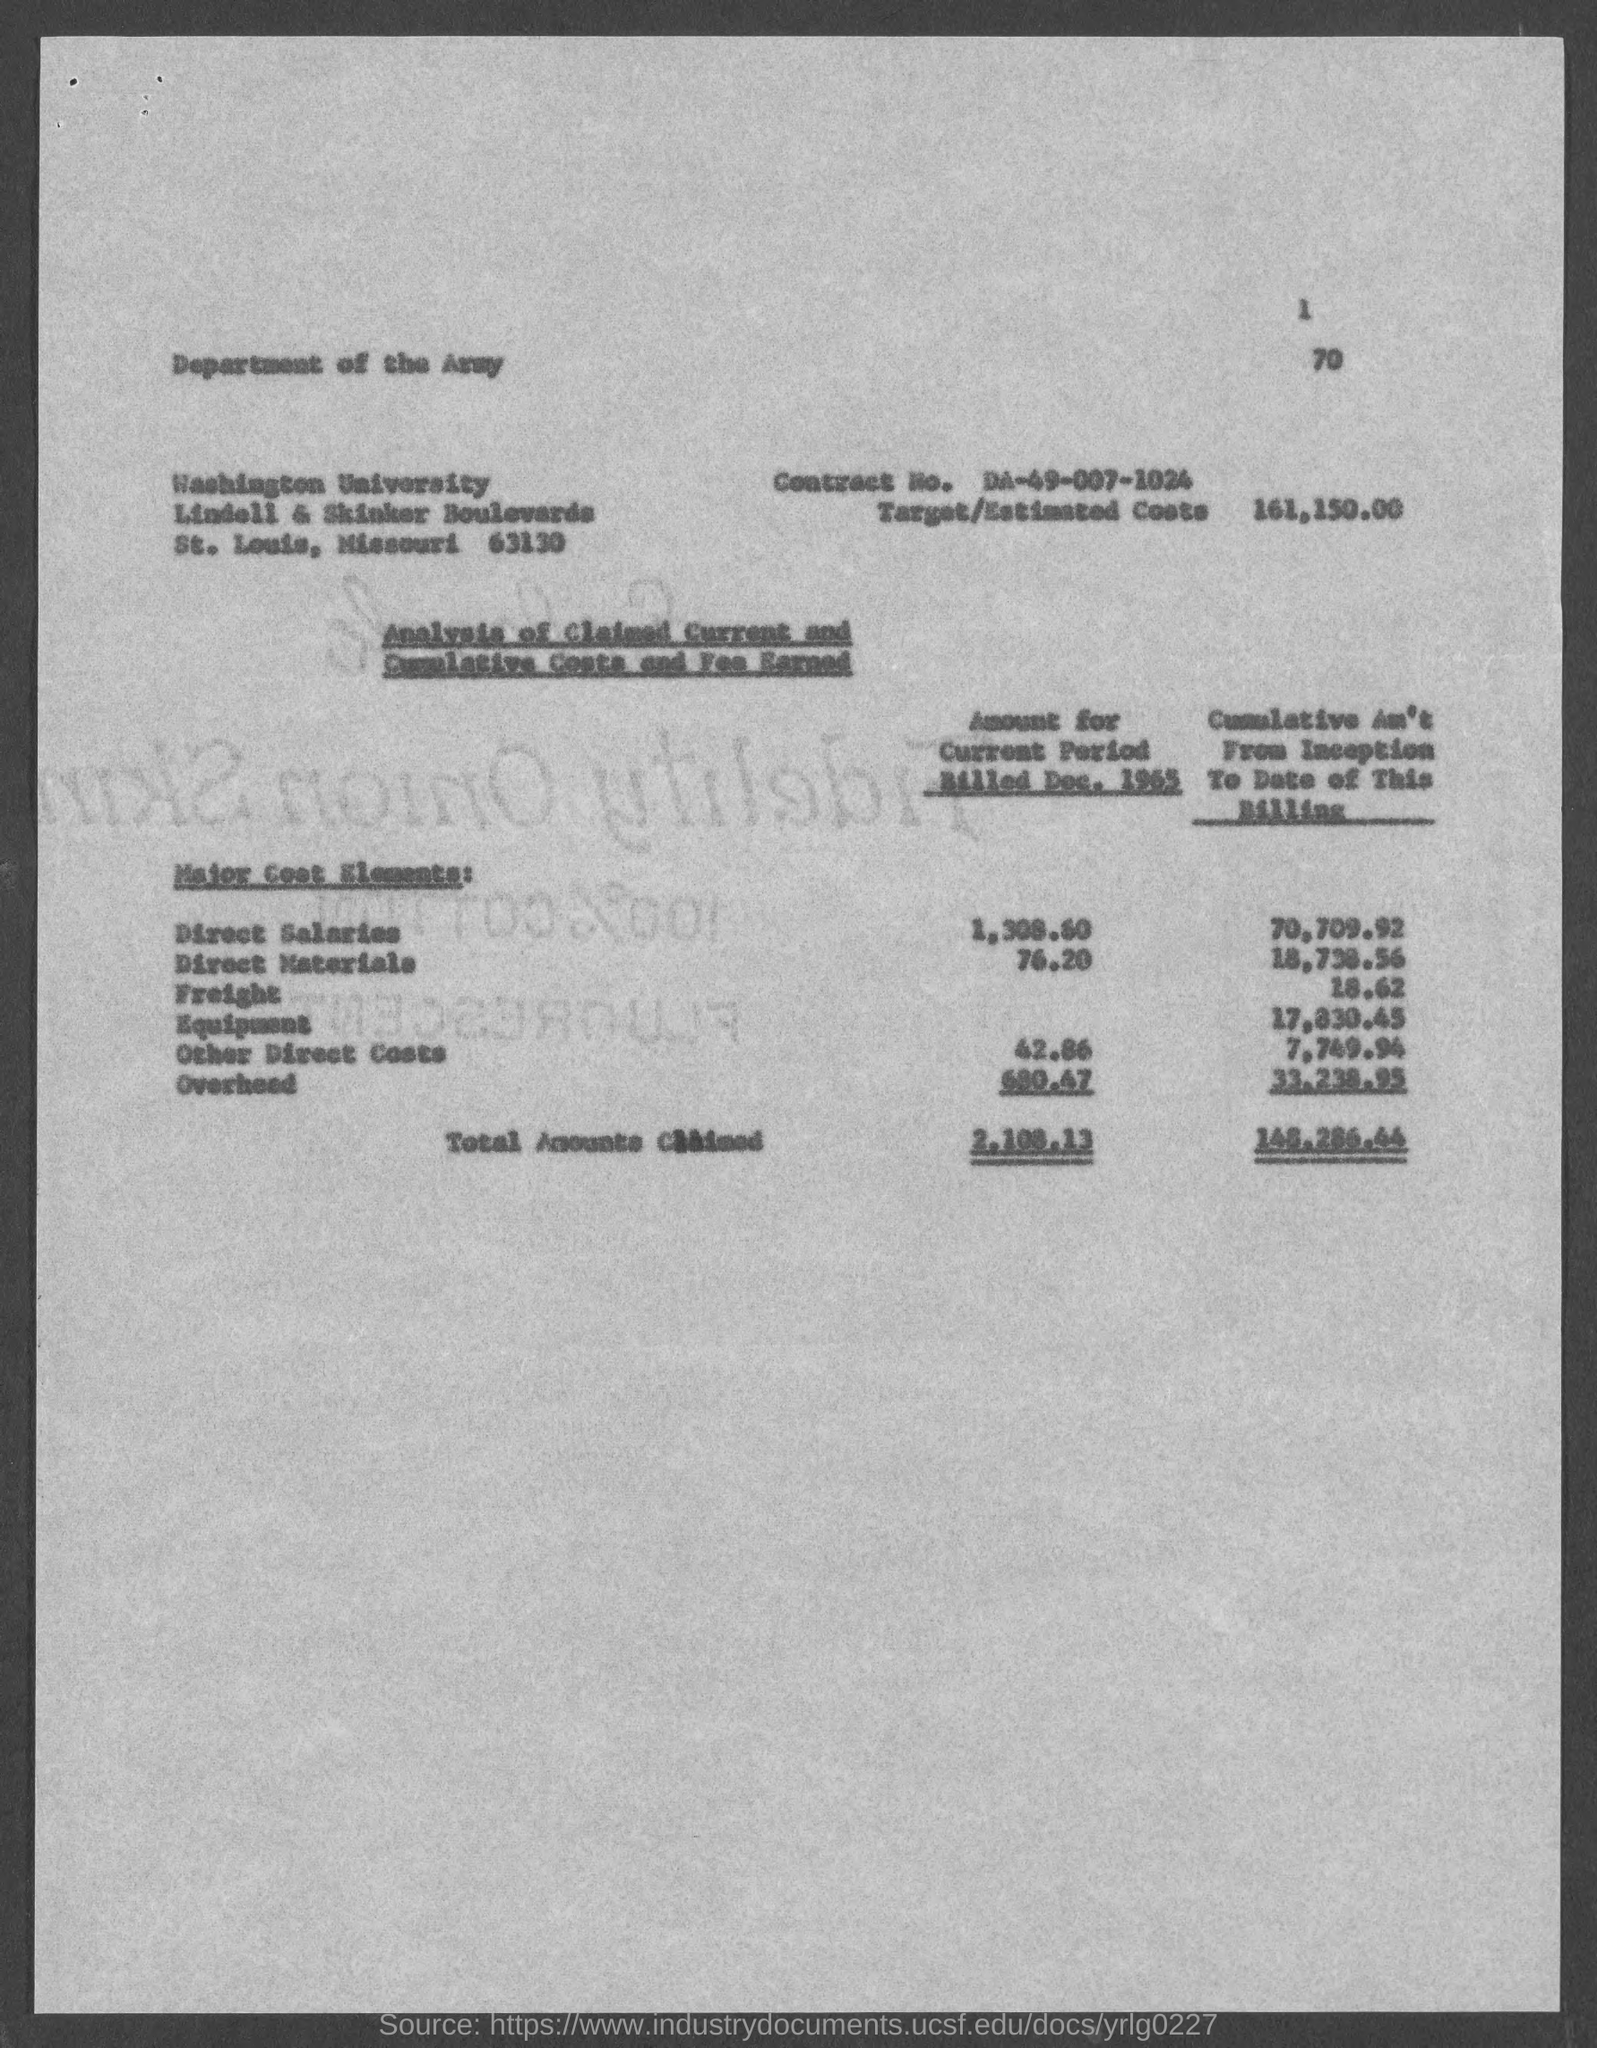What is the Target/Estimated costs given in the document?
Offer a terse response. 161,150.00. What is the direct materials amount for the current period billed in Dec. 1965?
Keep it short and to the point. 76.20. What is the cumulative amount for Freight from inception to date of this billing?
Your answer should be very brief. 18.62. What is the cumulative amount for equipment from inception to date of this billing?
Your response must be concise. 17,830.45. What is the total amount claimed for the current period billed in Dec. 1965?
Provide a short and direct response. 2,108.13. 